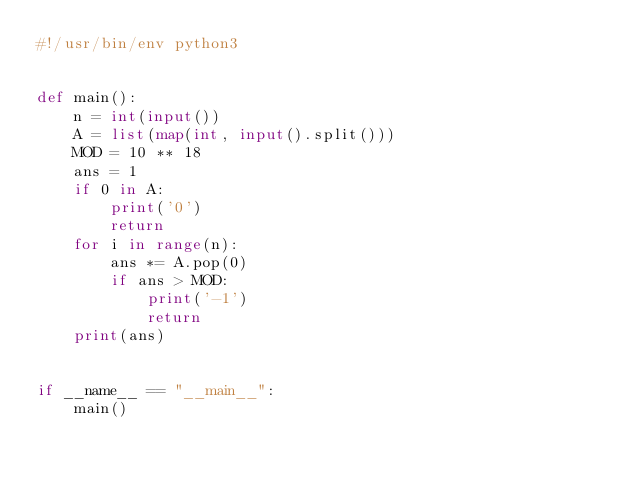Convert code to text. <code><loc_0><loc_0><loc_500><loc_500><_Python_>#!/usr/bin/env python3


def main():
    n = int(input())
    A = list(map(int, input().split()))
    MOD = 10 ** 18
    ans = 1
    if 0 in A:
        print('0')
        return
    for i in range(n):
        ans *= A.pop(0)
        if ans > MOD:
            print('-1')
            return
    print(ans)


if __name__ == "__main__":
    main()
</code> 